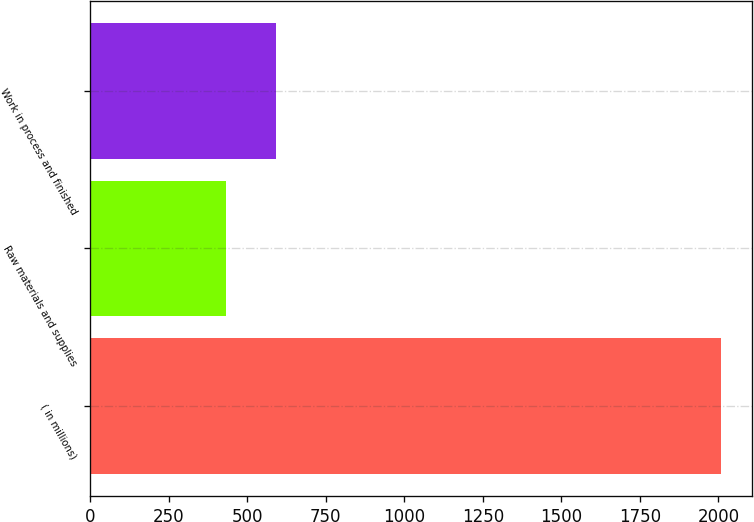Convert chart to OTSL. <chart><loc_0><loc_0><loc_500><loc_500><bar_chart><fcel>( in millions)<fcel>Raw materials and supplies<fcel>Work in process and finished<nl><fcel>2007<fcel>433.6<fcel>590.94<nl></chart> 